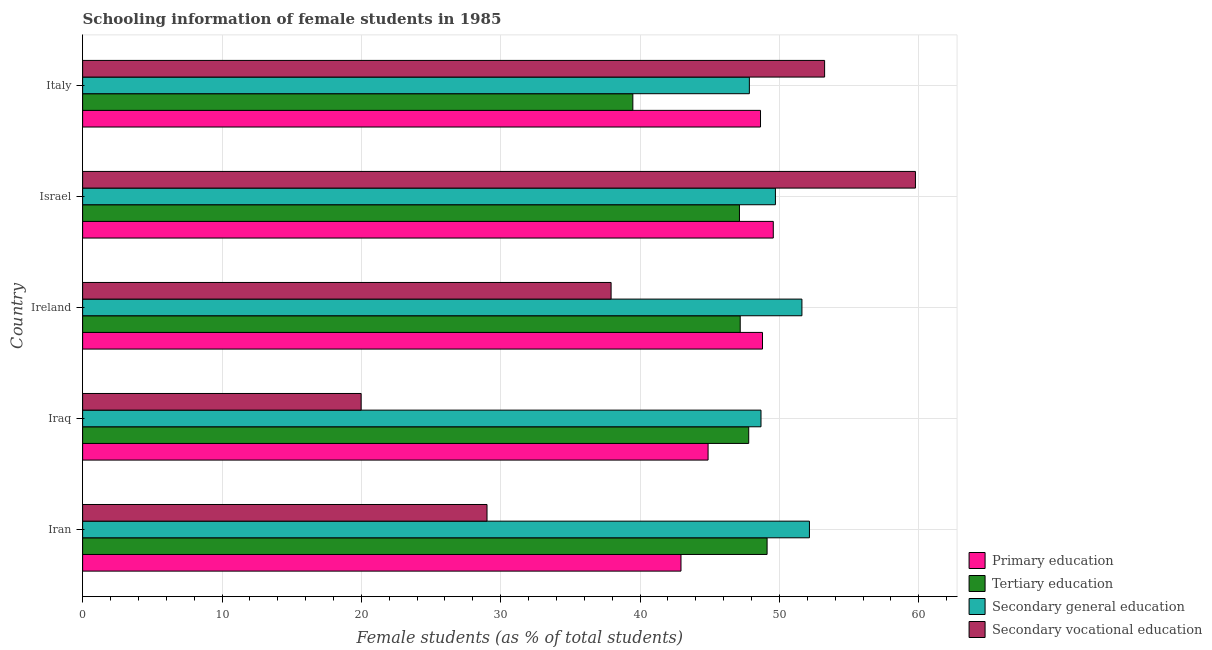How many different coloured bars are there?
Offer a terse response. 4. Are the number of bars per tick equal to the number of legend labels?
Offer a very short reply. Yes. How many bars are there on the 3rd tick from the top?
Provide a succinct answer. 4. How many bars are there on the 2nd tick from the bottom?
Your answer should be very brief. 4. What is the percentage of female students in primary education in Israel?
Your answer should be compact. 49.56. Across all countries, what is the maximum percentage of female students in secondary education?
Your answer should be compact. 52.15. Across all countries, what is the minimum percentage of female students in primary education?
Provide a short and direct response. 42.93. In which country was the percentage of female students in primary education minimum?
Ensure brevity in your answer.  Iran. What is the total percentage of female students in secondary vocational education in the graph?
Your response must be concise. 199.91. What is the difference between the percentage of female students in primary education in Iraq and that in Ireland?
Provide a short and direct response. -3.9. What is the difference between the percentage of female students in primary education in Israel and the percentage of female students in tertiary education in Ireland?
Give a very brief answer. 2.37. What is the average percentage of female students in secondary vocational education per country?
Provide a short and direct response. 39.98. What is the difference between the percentage of female students in secondary education and percentage of female students in tertiary education in Iran?
Provide a short and direct response. 3.04. What is the ratio of the percentage of female students in secondary education in Iraq to that in Ireland?
Offer a very short reply. 0.94. Is the difference between the percentage of female students in primary education in Ireland and Israel greater than the difference between the percentage of female students in secondary education in Ireland and Israel?
Ensure brevity in your answer.  No. What is the difference between the highest and the second highest percentage of female students in secondary vocational education?
Give a very brief answer. 6.52. What is the difference between the highest and the lowest percentage of female students in primary education?
Offer a very short reply. 6.62. Is the sum of the percentage of female students in primary education in Israel and Italy greater than the maximum percentage of female students in secondary vocational education across all countries?
Your response must be concise. Yes. What does the 2nd bar from the top in Italy represents?
Provide a succinct answer. Secondary general education. What does the 3rd bar from the bottom in Israel represents?
Keep it short and to the point. Secondary general education. Is it the case that in every country, the sum of the percentage of female students in primary education and percentage of female students in tertiary education is greater than the percentage of female students in secondary education?
Provide a succinct answer. Yes. How many bars are there?
Your answer should be compact. 20. Are all the bars in the graph horizontal?
Offer a terse response. Yes. How many countries are there in the graph?
Your answer should be very brief. 5. Where does the legend appear in the graph?
Your answer should be compact. Bottom right. What is the title of the graph?
Give a very brief answer. Schooling information of female students in 1985. What is the label or title of the X-axis?
Your response must be concise. Female students (as % of total students). What is the Female students (as % of total students) of Primary education in Iran?
Your answer should be very brief. 42.93. What is the Female students (as % of total students) in Tertiary education in Iran?
Your answer should be compact. 49.11. What is the Female students (as % of total students) in Secondary general education in Iran?
Provide a succinct answer. 52.15. What is the Female students (as % of total students) in Secondary vocational education in Iran?
Your answer should be very brief. 29.02. What is the Female students (as % of total students) of Primary education in Iraq?
Your answer should be compact. 44.88. What is the Female students (as % of total students) of Tertiary education in Iraq?
Make the answer very short. 47.79. What is the Female students (as % of total students) of Secondary general education in Iraq?
Offer a terse response. 48.68. What is the Female students (as % of total students) of Secondary vocational education in Iraq?
Offer a terse response. 19.98. What is the Female students (as % of total students) in Primary education in Ireland?
Give a very brief answer. 48.78. What is the Female students (as % of total students) of Tertiary education in Ireland?
Give a very brief answer. 47.18. What is the Female students (as % of total students) of Secondary general education in Ireland?
Offer a very short reply. 51.61. What is the Female students (as % of total students) in Secondary vocational education in Ireland?
Provide a short and direct response. 37.92. What is the Female students (as % of total students) in Primary education in Israel?
Provide a short and direct response. 49.56. What is the Female students (as % of total students) in Tertiary education in Israel?
Give a very brief answer. 47.13. What is the Female students (as % of total students) of Secondary general education in Israel?
Your response must be concise. 49.71. What is the Female students (as % of total students) in Secondary vocational education in Israel?
Make the answer very short. 59.76. What is the Female students (as % of total students) of Primary education in Italy?
Your response must be concise. 48.64. What is the Female students (as % of total students) of Tertiary education in Italy?
Your answer should be compact. 39.48. What is the Female students (as % of total students) in Secondary general education in Italy?
Your answer should be compact. 47.84. What is the Female students (as % of total students) in Secondary vocational education in Italy?
Make the answer very short. 53.24. Across all countries, what is the maximum Female students (as % of total students) in Primary education?
Your answer should be compact. 49.56. Across all countries, what is the maximum Female students (as % of total students) in Tertiary education?
Give a very brief answer. 49.11. Across all countries, what is the maximum Female students (as % of total students) of Secondary general education?
Provide a short and direct response. 52.15. Across all countries, what is the maximum Female students (as % of total students) of Secondary vocational education?
Your answer should be very brief. 59.76. Across all countries, what is the minimum Female students (as % of total students) in Primary education?
Your answer should be very brief. 42.93. Across all countries, what is the minimum Female students (as % of total students) in Tertiary education?
Give a very brief answer. 39.48. Across all countries, what is the minimum Female students (as % of total students) of Secondary general education?
Keep it short and to the point. 47.84. Across all countries, what is the minimum Female students (as % of total students) of Secondary vocational education?
Give a very brief answer. 19.98. What is the total Female students (as % of total students) in Primary education in the graph?
Your response must be concise. 234.79. What is the total Female students (as % of total students) in Tertiary education in the graph?
Offer a very short reply. 230.7. What is the total Female students (as % of total students) of Secondary general education in the graph?
Ensure brevity in your answer.  249.99. What is the total Female students (as % of total students) of Secondary vocational education in the graph?
Your response must be concise. 199.91. What is the difference between the Female students (as % of total students) in Primary education in Iran and that in Iraq?
Provide a short and direct response. -1.94. What is the difference between the Female students (as % of total students) in Tertiary education in Iran and that in Iraq?
Provide a succinct answer. 1.32. What is the difference between the Female students (as % of total students) in Secondary general education in Iran and that in Iraq?
Keep it short and to the point. 3.47. What is the difference between the Female students (as % of total students) in Secondary vocational education in Iran and that in Iraq?
Your answer should be very brief. 9.03. What is the difference between the Female students (as % of total students) of Primary education in Iran and that in Ireland?
Keep it short and to the point. -5.85. What is the difference between the Female students (as % of total students) of Tertiary education in Iran and that in Ireland?
Give a very brief answer. 1.93. What is the difference between the Female students (as % of total students) in Secondary general education in Iran and that in Ireland?
Offer a terse response. 0.54. What is the difference between the Female students (as % of total students) in Secondary vocational education in Iran and that in Ireland?
Your answer should be compact. -8.9. What is the difference between the Female students (as % of total students) of Primary education in Iran and that in Israel?
Ensure brevity in your answer.  -6.62. What is the difference between the Female students (as % of total students) in Tertiary education in Iran and that in Israel?
Your response must be concise. 1.98. What is the difference between the Female students (as % of total students) in Secondary general education in Iran and that in Israel?
Provide a succinct answer. 2.44. What is the difference between the Female students (as % of total students) in Secondary vocational education in Iran and that in Israel?
Make the answer very short. -30.74. What is the difference between the Female students (as % of total students) of Primary education in Iran and that in Italy?
Give a very brief answer. -5.71. What is the difference between the Female students (as % of total students) in Tertiary education in Iran and that in Italy?
Offer a very short reply. 9.63. What is the difference between the Female students (as % of total students) of Secondary general education in Iran and that in Italy?
Keep it short and to the point. 4.31. What is the difference between the Female students (as % of total students) of Secondary vocational education in Iran and that in Italy?
Your answer should be very brief. -24.22. What is the difference between the Female students (as % of total students) in Primary education in Iraq and that in Ireland?
Give a very brief answer. -3.9. What is the difference between the Female students (as % of total students) of Tertiary education in Iraq and that in Ireland?
Give a very brief answer. 0.61. What is the difference between the Female students (as % of total students) of Secondary general education in Iraq and that in Ireland?
Your response must be concise. -2.94. What is the difference between the Female students (as % of total students) of Secondary vocational education in Iraq and that in Ireland?
Ensure brevity in your answer.  -17.94. What is the difference between the Female students (as % of total students) in Primary education in Iraq and that in Israel?
Your response must be concise. -4.68. What is the difference between the Female students (as % of total students) in Tertiary education in Iraq and that in Israel?
Ensure brevity in your answer.  0.67. What is the difference between the Female students (as % of total students) of Secondary general education in Iraq and that in Israel?
Keep it short and to the point. -1.03. What is the difference between the Female students (as % of total students) in Secondary vocational education in Iraq and that in Israel?
Ensure brevity in your answer.  -39.77. What is the difference between the Female students (as % of total students) of Primary education in Iraq and that in Italy?
Make the answer very short. -3.76. What is the difference between the Female students (as % of total students) of Tertiary education in Iraq and that in Italy?
Keep it short and to the point. 8.31. What is the difference between the Female students (as % of total students) in Secondary general education in Iraq and that in Italy?
Offer a very short reply. 0.84. What is the difference between the Female students (as % of total students) in Secondary vocational education in Iraq and that in Italy?
Offer a very short reply. -33.26. What is the difference between the Female students (as % of total students) of Primary education in Ireland and that in Israel?
Provide a succinct answer. -0.77. What is the difference between the Female students (as % of total students) in Tertiary education in Ireland and that in Israel?
Make the answer very short. 0.06. What is the difference between the Female students (as % of total students) of Secondary general education in Ireland and that in Israel?
Ensure brevity in your answer.  1.9. What is the difference between the Female students (as % of total students) of Secondary vocational education in Ireland and that in Israel?
Provide a short and direct response. -21.84. What is the difference between the Female students (as % of total students) of Primary education in Ireland and that in Italy?
Make the answer very short. 0.14. What is the difference between the Female students (as % of total students) of Tertiary education in Ireland and that in Italy?
Offer a very short reply. 7.7. What is the difference between the Female students (as % of total students) of Secondary general education in Ireland and that in Italy?
Give a very brief answer. 3.77. What is the difference between the Female students (as % of total students) of Secondary vocational education in Ireland and that in Italy?
Provide a succinct answer. -15.32. What is the difference between the Female students (as % of total students) in Primary education in Israel and that in Italy?
Offer a terse response. 0.92. What is the difference between the Female students (as % of total students) in Tertiary education in Israel and that in Italy?
Offer a very short reply. 7.65. What is the difference between the Female students (as % of total students) in Secondary general education in Israel and that in Italy?
Provide a succinct answer. 1.87. What is the difference between the Female students (as % of total students) in Secondary vocational education in Israel and that in Italy?
Offer a very short reply. 6.52. What is the difference between the Female students (as % of total students) of Primary education in Iran and the Female students (as % of total students) of Tertiary education in Iraq?
Offer a terse response. -4.86. What is the difference between the Female students (as % of total students) of Primary education in Iran and the Female students (as % of total students) of Secondary general education in Iraq?
Provide a short and direct response. -5.74. What is the difference between the Female students (as % of total students) of Primary education in Iran and the Female students (as % of total students) of Secondary vocational education in Iraq?
Make the answer very short. 22.95. What is the difference between the Female students (as % of total students) of Tertiary education in Iran and the Female students (as % of total students) of Secondary general education in Iraq?
Keep it short and to the point. 0.44. What is the difference between the Female students (as % of total students) of Tertiary education in Iran and the Female students (as % of total students) of Secondary vocational education in Iraq?
Offer a terse response. 29.13. What is the difference between the Female students (as % of total students) of Secondary general education in Iran and the Female students (as % of total students) of Secondary vocational education in Iraq?
Ensure brevity in your answer.  32.17. What is the difference between the Female students (as % of total students) of Primary education in Iran and the Female students (as % of total students) of Tertiary education in Ireland?
Ensure brevity in your answer.  -4.25. What is the difference between the Female students (as % of total students) of Primary education in Iran and the Female students (as % of total students) of Secondary general education in Ireland?
Ensure brevity in your answer.  -8.68. What is the difference between the Female students (as % of total students) of Primary education in Iran and the Female students (as % of total students) of Secondary vocational education in Ireland?
Offer a terse response. 5.01. What is the difference between the Female students (as % of total students) of Tertiary education in Iran and the Female students (as % of total students) of Secondary general education in Ireland?
Ensure brevity in your answer.  -2.5. What is the difference between the Female students (as % of total students) in Tertiary education in Iran and the Female students (as % of total students) in Secondary vocational education in Ireland?
Provide a short and direct response. 11.19. What is the difference between the Female students (as % of total students) in Secondary general education in Iran and the Female students (as % of total students) in Secondary vocational education in Ireland?
Provide a succinct answer. 14.23. What is the difference between the Female students (as % of total students) of Primary education in Iran and the Female students (as % of total students) of Tertiary education in Israel?
Your answer should be compact. -4.19. What is the difference between the Female students (as % of total students) of Primary education in Iran and the Female students (as % of total students) of Secondary general education in Israel?
Ensure brevity in your answer.  -6.78. What is the difference between the Female students (as % of total students) of Primary education in Iran and the Female students (as % of total students) of Secondary vocational education in Israel?
Provide a succinct answer. -16.82. What is the difference between the Female students (as % of total students) in Tertiary education in Iran and the Female students (as % of total students) in Secondary general education in Israel?
Provide a succinct answer. -0.6. What is the difference between the Female students (as % of total students) of Tertiary education in Iran and the Female students (as % of total students) of Secondary vocational education in Israel?
Keep it short and to the point. -10.64. What is the difference between the Female students (as % of total students) in Secondary general education in Iran and the Female students (as % of total students) in Secondary vocational education in Israel?
Offer a very short reply. -7.61. What is the difference between the Female students (as % of total students) in Primary education in Iran and the Female students (as % of total students) in Tertiary education in Italy?
Ensure brevity in your answer.  3.45. What is the difference between the Female students (as % of total students) in Primary education in Iran and the Female students (as % of total students) in Secondary general education in Italy?
Your answer should be compact. -4.91. What is the difference between the Female students (as % of total students) of Primary education in Iran and the Female students (as % of total students) of Secondary vocational education in Italy?
Give a very brief answer. -10.3. What is the difference between the Female students (as % of total students) of Tertiary education in Iran and the Female students (as % of total students) of Secondary general education in Italy?
Keep it short and to the point. 1.27. What is the difference between the Female students (as % of total students) of Tertiary education in Iran and the Female students (as % of total students) of Secondary vocational education in Italy?
Offer a terse response. -4.13. What is the difference between the Female students (as % of total students) of Secondary general education in Iran and the Female students (as % of total students) of Secondary vocational education in Italy?
Your answer should be very brief. -1.09. What is the difference between the Female students (as % of total students) in Primary education in Iraq and the Female students (as % of total students) in Tertiary education in Ireland?
Your response must be concise. -2.31. What is the difference between the Female students (as % of total students) of Primary education in Iraq and the Female students (as % of total students) of Secondary general education in Ireland?
Make the answer very short. -6.73. What is the difference between the Female students (as % of total students) in Primary education in Iraq and the Female students (as % of total students) in Secondary vocational education in Ireland?
Your answer should be very brief. 6.96. What is the difference between the Female students (as % of total students) in Tertiary education in Iraq and the Female students (as % of total students) in Secondary general education in Ireland?
Offer a terse response. -3.82. What is the difference between the Female students (as % of total students) of Tertiary education in Iraq and the Female students (as % of total students) of Secondary vocational education in Ireland?
Provide a short and direct response. 9.87. What is the difference between the Female students (as % of total students) in Secondary general education in Iraq and the Female students (as % of total students) in Secondary vocational education in Ireland?
Provide a succinct answer. 10.76. What is the difference between the Female students (as % of total students) of Primary education in Iraq and the Female students (as % of total students) of Tertiary education in Israel?
Keep it short and to the point. -2.25. What is the difference between the Female students (as % of total students) in Primary education in Iraq and the Female students (as % of total students) in Secondary general education in Israel?
Keep it short and to the point. -4.83. What is the difference between the Female students (as % of total students) of Primary education in Iraq and the Female students (as % of total students) of Secondary vocational education in Israel?
Give a very brief answer. -14.88. What is the difference between the Female students (as % of total students) of Tertiary education in Iraq and the Female students (as % of total students) of Secondary general education in Israel?
Ensure brevity in your answer.  -1.92. What is the difference between the Female students (as % of total students) of Tertiary education in Iraq and the Female students (as % of total students) of Secondary vocational education in Israel?
Ensure brevity in your answer.  -11.96. What is the difference between the Female students (as % of total students) of Secondary general education in Iraq and the Female students (as % of total students) of Secondary vocational education in Israel?
Provide a succinct answer. -11.08. What is the difference between the Female students (as % of total students) in Primary education in Iraq and the Female students (as % of total students) in Tertiary education in Italy?
Offer a terse response. 5.4. What is the difference between the Female students (as % of total students) in Primary education in Iraq and the Female students (as % of total students) in Secondary general education in Italy?
Ensure brevity in your answer.  -2.96. What is the difference between the Female students (as % of total students) of Primary education in Iraq and the Female students (as % of total students) of Secondary vocational education in Italy?
Provide a short and direct response. -8.36. What is the difference between the Female students (as % of total students) of Tertiary education in Iraq and the Female students (as % of total students) of Secondary general education in Italy?
Your response must be concise. -0.05. What is the difference between the Female students (as % of total students) of Tertiary education in Iraq and the Female students (as % of total students) of Secondary vocational education in Italy?
Offer a very short reply. -5.45. What is the difference between the Female students (as % of total students) in Secondary general education in Iraq and the Female students (as % of total students) in Secondary vocational education in Italy?
Offer a very short reply. -4.56. What is the difference between the Female students (as % of total students) of Primary education in Ireland and the Female students (as % of total students) of Tertiary education in Israel?
Keep it short and to the point. 1.65. What is the difference between the Female students (as % of total students) of Primary education in Ireland and the Female students (as % of total students) of Secondary general education in Israel?
Your answer should be very brief. -0.93. What is the difference between the Female students (as % of total students) in Primary education in Ireland and the Female students (as % of total students) in Secondary vocational education in Israel?
Ensure brevity in your answer.  -10.97. What is the difference between the Female students (as % of total students) in Tertiary education in Ireland and the Female students (as % of total students) in Secondary general education in Israel?
Your answer should be compact. -2.53. What is the difference between the Female students (as % of total students) in Tertiary education in Ireland and the Female students (as % of total students) in Secondary vocational education in Israel?
Your answer should be compact. -12.57. What is the difference between the Female students (as % of total students) in Secondary general education in Ireland and the Female students (as % of total students) in Secondary vocational education in Israel?
Provide a short and direct response. -8.14. What is the difference between the Female students (as % of total students) of Primary education in Ireland and the Female students (as % of total students) of Tertiary education in Italy?
Ensure brevity in your answer.  9.3. What is the difference between the Female students (as % of total students) of Primary education in Ireland and the Female students (as % of total students) of Secondary general education in Italy?
Keep it short and to the point. 0.94. What is the difference between the Female students (as % of total students) in Primary education in Ireland and the Female students (as % of total students) in Secondary vocational education in Italy?
Provide a short and direct response. -4.46. What is the difference between the Female students (as % of total students) of Tertiary education in Ireland and the Female students (as % of total students) of Secondary general education in Italy?
Ensure brevity in your answer.  -0.66. What is the difference between the Female students (as % of total students) in Tertiary education in Ireland and the Female students (as % of total students) in Secondary vocational education in Italy?
Your response must be concise. -6.06. What is the difference between the Female students (as % of total students) in Secondary general education in Ireland and the Female students (as % of total students) in Secondary vocational education in Italy?
Ensure brevity in your answer.  -1.63. What is the difference between the Female students (as % of total students) in Primary education in Israel and the Female students (as % of total students) in Tertiary education in Italy?
Your answer should be compact. 10.08. What is the difference between the Female students (as % of total students) in Primary education in Israel and the Female students (as % of total students) in Secondary general education in Italy?
Your answer should be very brief. 1.72. What is the difference between the Female students (as % of total students) of Primary education in Israel and the Female students (as % of total students) of Secondary vocational education in Italy?
Your answer should be very brief. -3.68. What is the difference between the Female students (as % of total students) in Tertiary education in Israel and the Female students (as % of total students) in Secondary general education in Italy?
Give a very brief answer. -0.71. What is the difference between the Female students (as % of total students) of Tertiary education in Israel and the Female students (as % of total students) of Secondary vocational education in Italy?
Ensure brevity in your answer.  -6.11. What is the difference between the Female students (as % of total students) of Secondary general education in Israel and the Female students (as % of total students) of Secondary vocational education in Italy?
Ensure brevity in your answer.  -3.53. What is the average Female students (as % of total students) of Primary education per country?
Offer a terse response. 46.96. What is the average Female students (as % of total students) of Tertiary education per country?
Keep it short and to the point. 46.14. What is the average Female students (as % of total students) in Secondary general education per country?
Provide a succinct answer. 50. What is the average Female students (as % of total students) of Secondary vocational education per country?
Offer a very short reply. 39.98. What is the difference between the Female students (as % of total students) of Primary education and Female students (as % of total students) of Tertiary education in Iran?
Give a very brief answer. -6.18. What is the difference between the Female students (as % of total students) in Primary education and Female students (as % of total students) in Secondary general education in Iran?
Provide a short and direct response. -9.22. What is the difference between the Female students (as % of total students) in Primary education and Female students (as % of total students) in Secondary vocational education in Iran?
Your answer should be compact. 13.92. What is the difference between the Female students (as % of total students) of Tertiary education and Female students (as % of total students) of Secondary general education in Iran?
Keep it short and to the point. -3.04. What is the difference between the Female students (as % of total students) of Tertiary education and Female students (as % of total students) of Secondary vocational education in Iran?
Your answer should be very brief. 20.1. What is the difference between the Female students (as % of total students) in Secondary general education and Female students (as % of total students) in Secondary vocational education in Iran?
Offer a very short reply. 23.13. What is the difference between the Female students (as % of total students) in Primary education and Female students (as % of total students) in Tertiary education in Iraq?
Ensure brevity in your answer.  -2.92. What is the difference between the Female students (as % of total students) of Primary education and Female students (as % of total students) of Secondary general education in Iraq?
Give a very brief answer. -3.8. What is the difference between the Female students (as % of total students) in Primary education and Female students (as % of total students) in Secondary vocational education in Iraq?
Provide a succinct answer. 24.89. What is the difference between the Female students (as % of total students) of Tertiary education and Female students (as % of total students) of Secondary general education in Iraq?
Ensure brevity in your answer.  -0.88. What is the difference between the Female students (as % of total students) in Tertiary education and Female students (as % of total students) in Secondary vocational education in Iraq?
Offer a terse response. 27.81. What is the difference between the Female students (as % of total students) in Secondary general education and Female students (as % of total students) in Secondary vocational education in Iraq?
Provide a succinct answer. 28.69. What is the difference between the Female students (as % of total students) in Primary education and Female students (as % of total students) in Tertiary education in Ireland?
Make the answer very short. 1.6. What is the difference between the Female students (as % of total students) in Primary education and Female students (as % of total students) in Secondary general education in Ireland?
Offer a terse response. -2.83. What is the difference between the Female students (as % of total students) in Primary education and Female students (as % of total students) in Secondary vocational education in Ireland?
Your answer should be compact. 10.86. What is the difference between the Female students (as % of total students) in Tertiary education and Female students (as % of total students) in Secondary general education in Ireland?
Offer a terse response. -4.43. What is the difference between the Female students (as % of total students) in Tertiary education and Female students (as % of total students) in Secondary vocational education in Ireland?
Make the answer very short. 9.26. What is the difference between the Female students (as % of total students) of Secondary general education and Female students (as % of total students) of Secondary vocational education in Ireland?
Make the answer very short. 13.69. What is the difference between the Female students (as % of total students) of Primary education and Female students (as % of total students) of Tertiary education in Israel?
Make the answer very short. 2.43. What is the difference between the Female students (as % of total students) of Primary education and Female students (as % of total students) of Secondary general education in Israel?
Your answer should be very brief. -0.15. What is the difference between the Female students (as % of total students) in Primary education and Female students (as % of total students) in Secondary vocational education in Israel?
Give a very brief answer. -10.2. What is the difference between the Female students (as % of total students) of Tertiary education and Female students (as % of total students) of Secondary general education in Israel?
Ensure brevity in your answer.  -2.58. What is the difference between the Female students (as % of total students) in Tertiary education and Female students (as % of total students) in Secondary vocational education in Israel?
Your answer should be compact. -12.63. What is the difference between the Female students (as % of total students) of Secondary general education and Female students (as % of total students) of Secondary vocational education in Israel?
Give a very brief answer. -10.05. What is the difference between the Female students (as % of total students) in Primary education and Female students (as % of total students) in Tertiary education in Italy?
Your answer should be compact. 9.16. What is the difference between the Female students (as % of total students) in Primary education and Female students (as % of total students) in Secondary general education in Italy?
Ensure brevity in your answer.  0.8. What is the difference between the Female students (as % of total students) in Primary education and Female students (as % of total students) in Secondary vocational education in Italy?
Provide a short and direct response. -4.6. What is the difference between the Female students (as % of total students) of Tertiary education and Female students (as % of total students) of Secondary general education in Italy?
Your answer should be very brief. -8.36. What is the difference between the Female students (as % of total students) of Tertiary education and Female students (as % of total students) of Secondary vocational education in Italy?
Make the answer very short. -13.76. What is the difference between the Female students (as % of total students) of Secondary general education and Female students (as % of total students) of Secondary vocational education in Italy?
Offer a terse response. -5.4. What is the ratio of the Female students (as % of total students) of Primary education in Iran to that in Iraq?
Give a very brief answer. 0.96. What is the ratio of the Female students (as % of total students) of Tertiary education in Iran to that in Iraq?
Make the answer very short. 1.03. What is the ratio of the Female students (as % of total students) of Secondary general education in Iran to that in Iraq?
Ensure brevity in your answer.  1.07. What is the ratio of the Female students (as % of total students) of Secondary vocational education in Iran to that in Iraq?
Ensure brevity in your answer.  1.45. What is the ratio of the Female students (as % of total students) of Primary education in Iran to that in Ireland?
Give a very brief answer. 0.88. What is the ratio of the Female students (as % of total students) of Tertiary education in Iran to that in Ireland?
Offer a terse response. 1.04. What is the ratio of the Female students (as % of total students) of Secondary general education in Iran to that in Ireland?
Your answer should be very brief. 1.01. What is the ratio of the Female students (as % of total students) of Secondary vocational education in Iran to that in Ireland?
Ensure brevity in your answer.  0.77. What is the ratio of the Female students (as % of total students) in Primary education in Iran to that in Israel?
Ensure brevity in your answer.  0.87. What is the ratio of the Female students (as % of total students) in Tertiary education in Iran to that in Israel?
Make the answer very short. 1.04. What is the ratio of the Female students (as % of total students) of Secondary general education in Iran to that in Israel?
Your answer should be very brief. 1.05. What is the ratio of the Female students (as % of total students) of Secondary vocational education in Iran to that in Israel?
Offer a very short reply. 0.49. What is the ratio of the Female students (as % of total students) of Primary education in Iran to that in Italy?
Provide a succinct answer. 0.88. What is the ratio of the Female students (as % of total students) in Tertiary education in Iran to that in Italy?
Give a very brief answer. 1.24. What is the ratio of the Female students (as % of total students) in Secondary general education in Iran to that in Italy?
Your answer should be compact. 1.09. What is the ratio of the Female students (as % of total students) of Secondary vocational education in Iran to that in Italy?
Your response must be concise. 0.55. What is the ratio of the Female students (as % of total students) in Tertiary education in Iraq to that in Ireland?
Your answer should be very brief. 1.01. What is the ratio of the Female students (as % of total students) in Secondary general education in Iraq to that in Ireland?
Provide a short and direct response. 0.94. What is the ratio of the Female students (as % of total students) of Secondary vocational education in Iraq to that in Ireland?
Your answer should be compact. 0.53. What is the ratio of the Female students (as % of total students) in Primary education in Iraq to that in Israel?
Ensure brevity in your answer.  0.91. What is the ratio of the Female students (as % of total students) in Tertiary education in Iraq to that in Israel?
Your response must be concise. 1.01. What is the ratio of the Female students (as % of total students) of Secondary general education in Iraq to that in Israel?
Ensure brevity in your answer.  0.98. What is the ratio of the Female students (as % of total students) in Secondary vocational education in Iraq to that in Israel?
Provide a short and direct response. 0.33. What is the ratio of the Female students (as % of total students) of Primary education in Iraq to that in Italy?
Your answer should be compact. 0.92. What is the ratio of the Female students (as % of total students) of Tertiary education in Iraq to that in Italy?
Your answer should be very brief. 1.21. What is the ratio of the Female students (as % of total students) in Secondary general education in Iraq to that in Italy?
Your response must be concise. 1.02. What is the ratio of the Female students (as % of total students) in Secondary vocational education in Iraq to that in Italy?
Your answer should be compact. 0.38. What is the ratio of the Female students (as % of total students) of Primary education in Ireland to that in Israel?
Keep it short and to the point. 0.98. What is the ratio of the Female students (as % of total students) of Tertiary education in Ireland to that in Israel?
Keep it short and to the point. 1. What is the ratio of the Female students (as % of total students) in Secondary general education in Ireland to that in Israel?
Offer a terse response. 1.04. What is the ratio of the Female students (as % of total students) in Secondary vocational education in Ireland to that in Israel?
Your answer should be very brief. 0.63. What is the ratio of the Female students (as % of total students) in Primary education in Ireland to that in Italy?
Keep it short and to the point. 1. What is the ratio of the Female students (as % of total students) of Tertiary education in Ireland to that in Italy?
Offer a terse response. 1.2. What is the ratio of the Female students (as % of total students) in Secondary general education in Ireland to that in Italy?
Make the answer very short. 1.08. What is the ratio of the Female students (as % of total students) of Secondary vocational education in Ireland to that in Italy?
Offer a very short reply. 0.71. What is the ratio of the Female students (as % of total students) in Primary education in Israel to that in Italy?
Offer a very short reply. 1.02. What is the ratio of the Female students (as % of total students) in Tertiary education in Israel to that in Italy?
Keep it short and to the point. 1.19. What is the ratio of the Female students (as % of total students) in Secondary general education in Israel to that in Italy?
Your answer should be very brief. 1.04. What is the ratio of the Female students (as % of total students) in Secondary vocational education in Israel to that in Italy?
Your answer should be compact. 1.12. What is the difference between the highest and the second highest Female students (as % of total students) of Primary education?
Your answer should be very brief. 0.77. What is the difference between the highest and the second highest Female students (as % of total students) in Tertiary education?
Your answer should be compact. 1.32. What is the difference between the highest and the second highest Female students (as % of total students) of Secondary general education?
Provide a short and direct response. 0.54. What is the difference between the highest and the second highest Female students (as % of total students) of Secondary vocational education?
Ensure brevity in your answer.  6.52. What is the difference between the highest and the lowest Female students (as % of total students) of Primary education?
Your response must be concise. 6.62. What is the difference between the highest and the lowest Female students (as % of total students) in Tertiary education?
Your response must be concise. 9.63. What is the difference between the highest and the lowest Female students (as % of total students) of Secondary general education?
Make the answer very short. 4.31. What is the difference between the highest and the lowest Female students (as % of total students) in Secondary vocational education?
Your response must be concise. 39.77. 